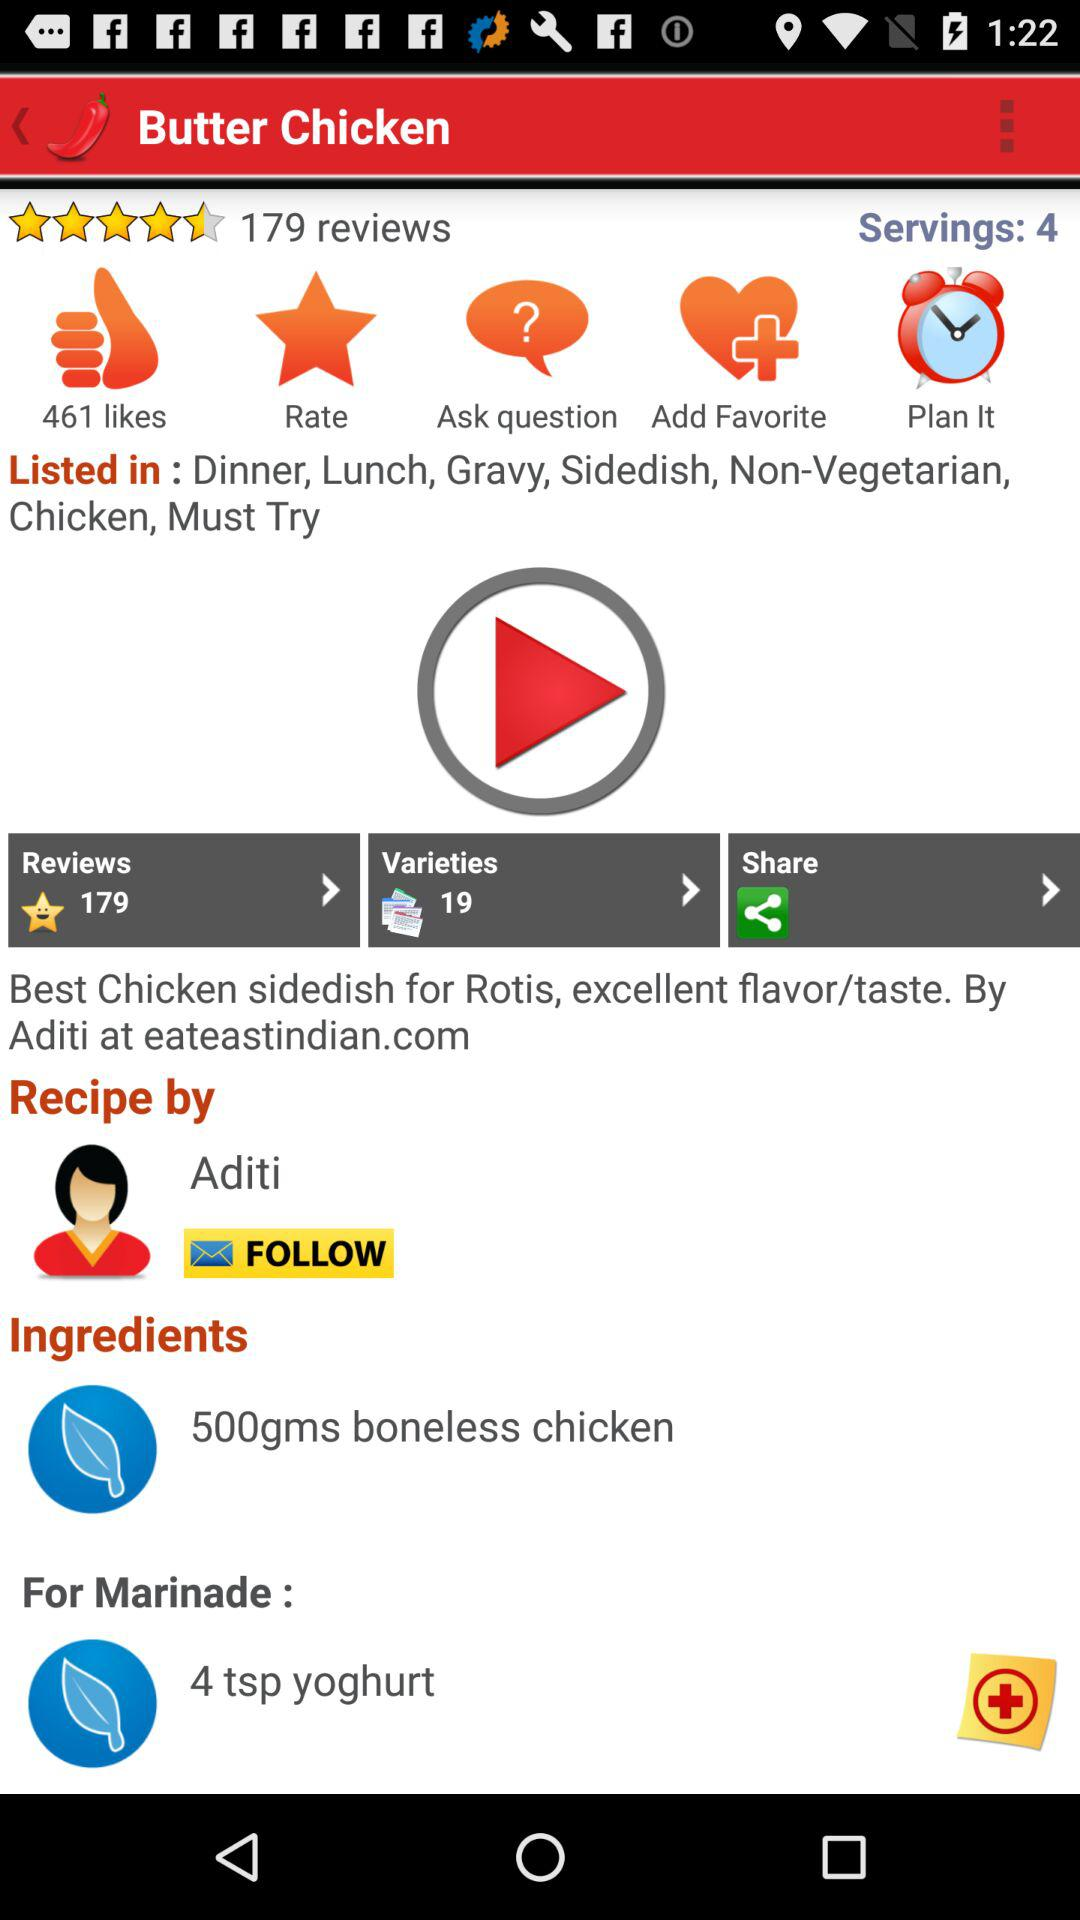What is the number of servings? The number of servings is 4. 